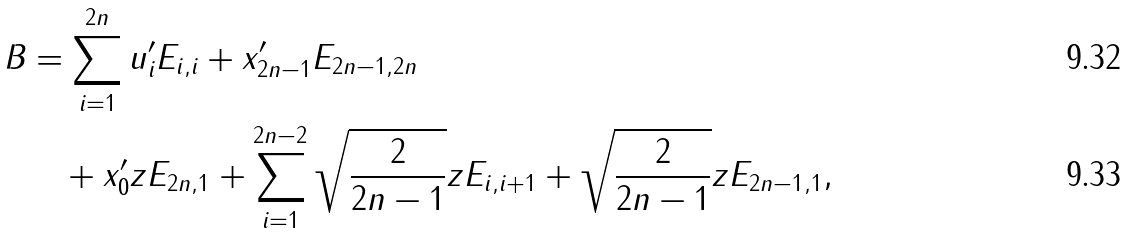<formula> <loc_0><loc_0><loc_500><loc_500>B & = \sum _ { i = 1 } ^ { 2 n } u ^ { \prime } _ { i } E _ { i , i } + x ^ { \prime } _ { 2 n - 1 } E _ { 2 n - 1 , 2 n } \\ & \quad + x ^ { \prime } _ { 0 } z E _ { 2 n , 1 } + \sum _ { i = 1 } ^ { 2 n - 2 } \sqrt { \frac { 2 } { 2 n - 1 } } z E _ { i , i + 1 } + \sqrt { \frac { 2 } { 2 n - 1 } } z E _ { 2 n - 1 , 1 } ,</formula> 